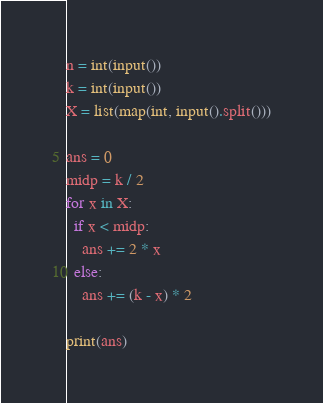Convert code to text. <code><loc_0><loc_0><loc_500><loc_500><_Python_>n = int(input())
k = int(input())
X = list(map(int, input().split()))

ans = 0
midp = k / 2
for x in X:
  if x < midp:
    ans += 2 * x
  else:
    ans += (k - x) * 2

print(ans)</code> 